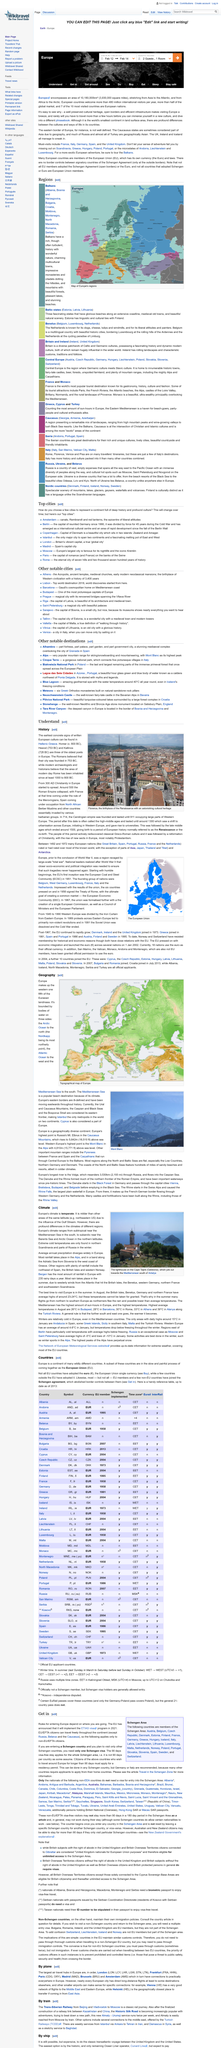Outline some significant characteristics in this image. The Carolingian empire was founded in 714. The most rain occurs in the summer in Europe. Cape Taslik, located south of Antalya, can be found through a combination of a map and compass navigation. The late Middle Ages ended in the year 1500. Europe's climate is significantly milder than that of the northeastern United States. 